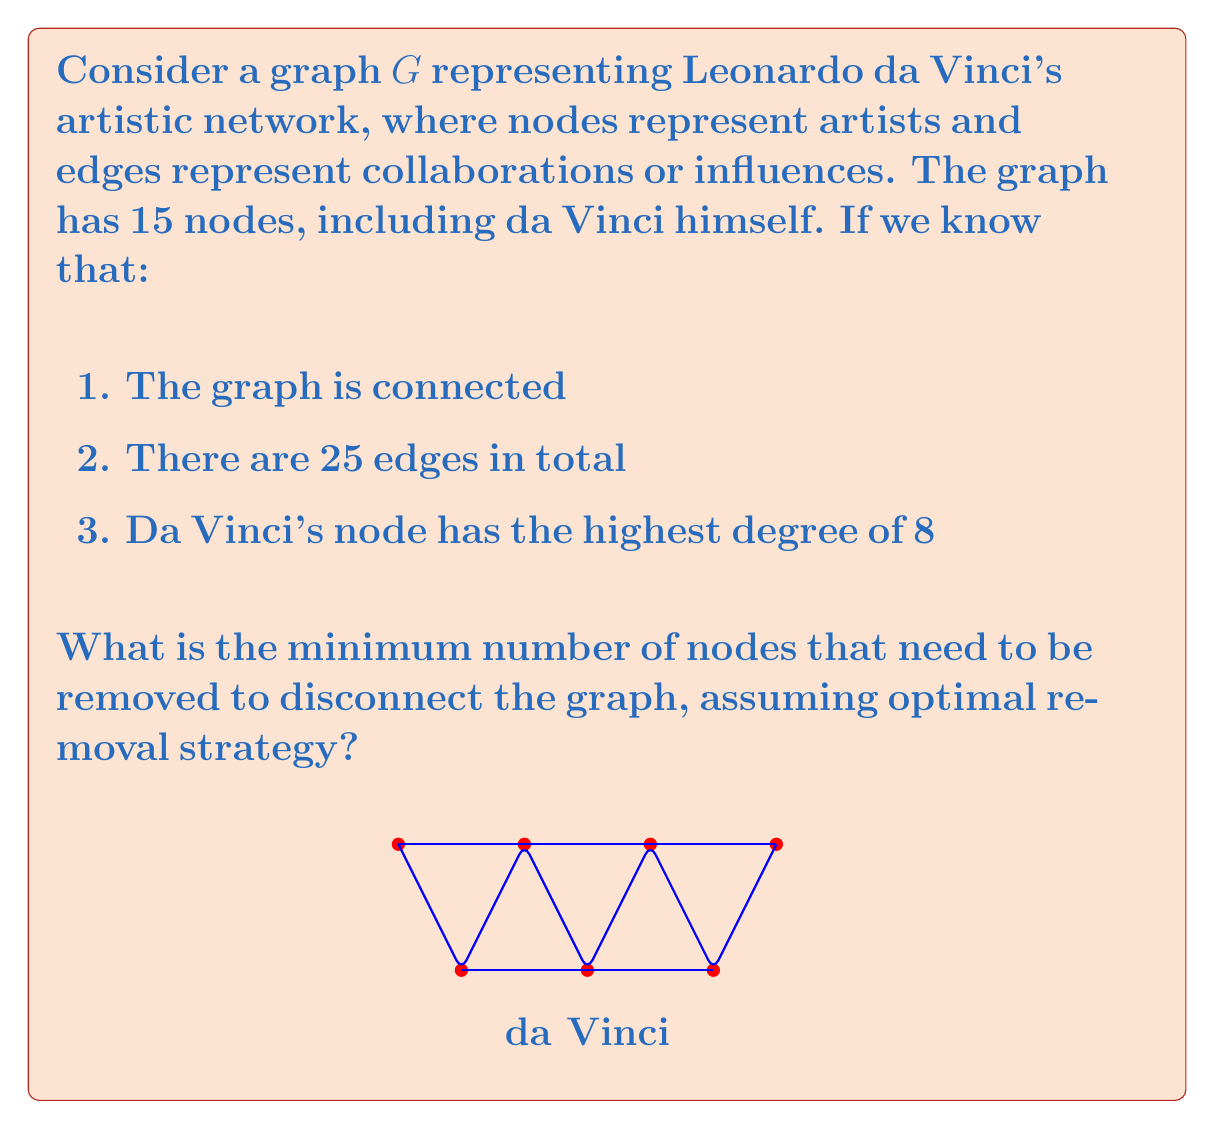Help me with this question. To solve this problem, we need to understand the concept of vertex connectivity in graph theory. The vertex connectivity of a graph is the minimum number of vertices that need to be removed to disconnect the graph.

Let's approach this step-by-step:

1) First, we know that the graph is connected and has 15 nodes and 25 edges. This means it's not a complete graph (which would have $\binom{15}{2} = 105$ edges).

2) Da Vinci's node has the highest degree of 8, meaning it's connected to 8 other nodes. This is a crucial piece of information.

3) In graph theory, the vertex connectivity is always less than or equal to the minimum degree of the graph. Since da Vinci's node has the highest degree (8), and the graph is not complete, there must be nodes with degree less than 8.

4) However, we don't know the exact degree of other nodes. In the worst case (for disconnecting the graph), the graph could be as connected as possible while still satisfying the given conditions.

5) In such a case, removing da Vinci's node would leave us with 14 nodes and at most 17 edges (25 - 8). This could still potentially be a connected graph.

6) The most resilient structure for these remaining nodes would be if they formed a cycle with some additional edges. A cycle of 14 nodes would use 14 edges, leaving 3 edges to strengthen the structure.

7) In this scenario, we would need to remove at least 3 nodes to disconnect the graph: da Vinci's node and two nodes from the hypothetical cycle.

Therefore, the minimum number of nodes that need to be removed to disconnect the graph is 3.
Answer: 3 